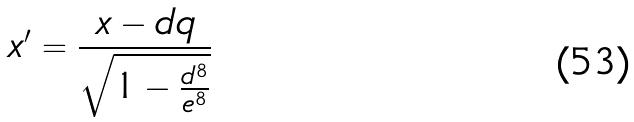<formula> <loc_0><loc_0><loc_500><loc_500>x ^ { \prime } = \frac { x - d q } { \sqrt { 1 - \frac { d ^ { 8 } } { e ^ { 8 } } } }</formula> 